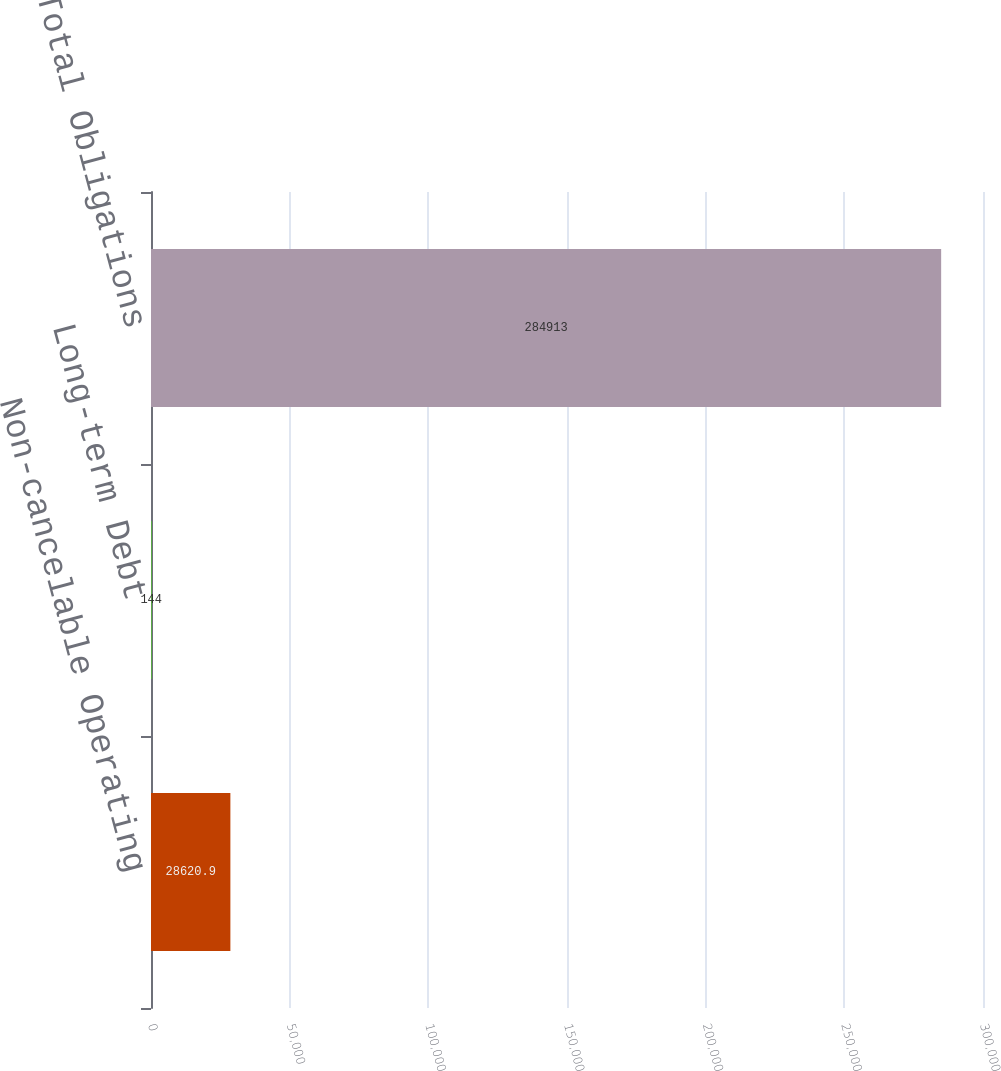Convert chart to OTSL. <chart><loc_0><loc_0><loc_500><loc_500><bar_chart><fcel>Non-cancelable Operating<fcel>Long-term Debt<fcel>Total Obligations<nl><fcel>28620.9<fcel>144<fcel>284913<nl></chart> 